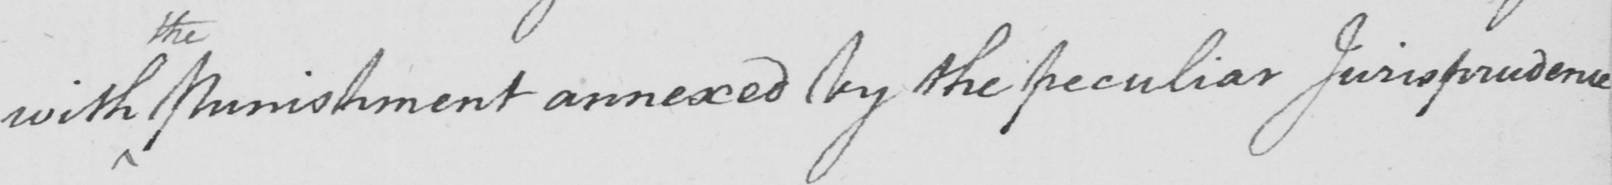Can you tell me what this handwritten text says? with Punishment annexed by the peculiar Jurisprudence 